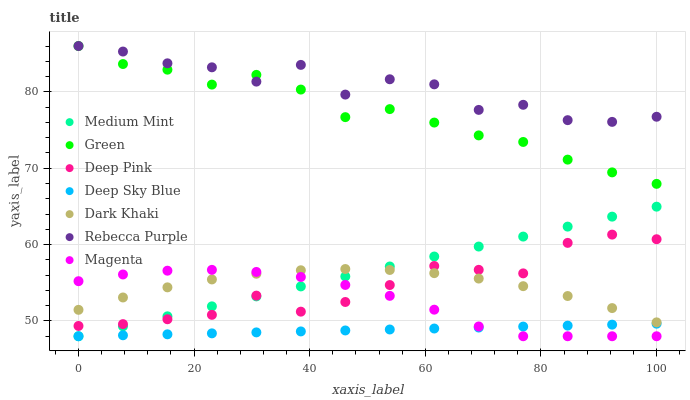Does Deep Sky Blue have the minimum area under the curve?
Answer yes or no. Yes. Does Rebecca Purple have the maximum area under the curve?
Answer yes or no. Yes. Does Deep Pink have the minimum area under the curve?
Answer yes or no. No. Does Deep Pink have the maximum area under the curve?
Answer yes or no. No. Is Medium Mint the smoothest?
Answer yes or no. Yes. Is Rebecca Purple the roughest?
Answer yes or no. Yes. Is Deep Pink the smoothest?
Answer yes or no. No. Is Deep Pink the roughest?
Answer yes or no. No. Does Medium Mint have the lowest value?
Answer yes or no. Yes. Does Deep Pink have the lowest value?
Answer yes or no. No. Does Rebecca Purple have the highest value?
Answer yes or no. Yes. Does Deep Pink have the highest value?
Answer yes or no. No. Is Deep Pink less than Rebecca Purple?
Answer yes or no. Yes. Is Rebecca Purple greater than Deep Sky Blue?
Answer yes or no. Yes. Does Dark Khaki intersect Magenta?
Answer yes or no. Yes. Is Dark Khaki less than Magenta?
Answer yes or no. No. Is Dark Khaki greater than Magenta?
Answer yes or no. No. Does Deep Pink intersect Rebecca Purple?
Answer yes or no. No. 